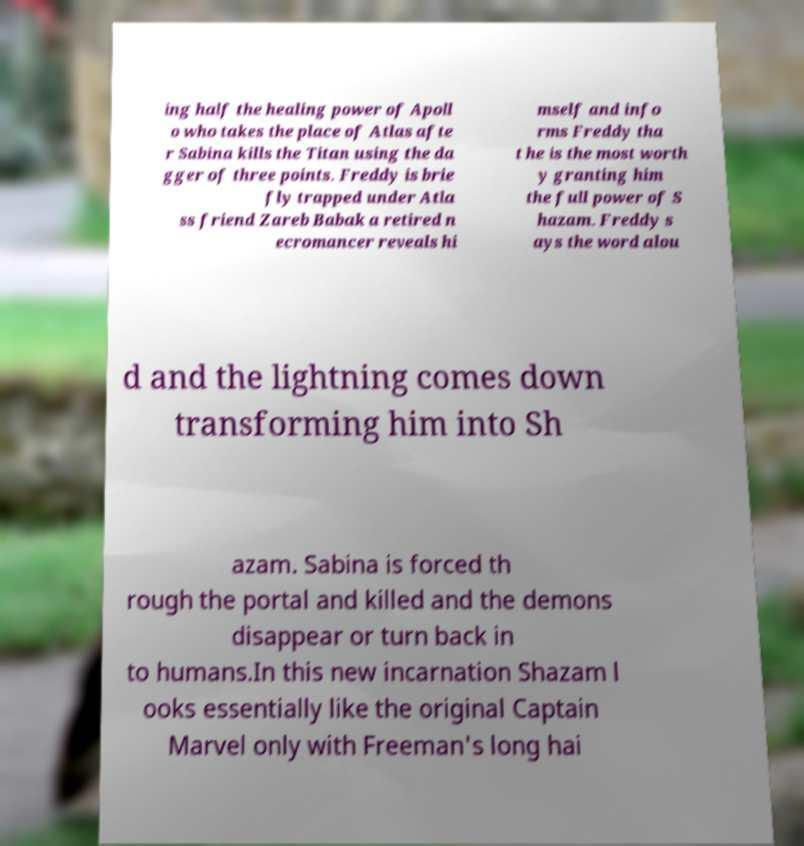Can you accurately transcribe the text from the provided image for me? ing half the healing power of Apoll o who takes the place of Atlas afte r Sabina kills the Titan using the da gger of three points. Freddy is brie fly trapped under Atla ss friend Zareb Babak a retired n ecromancer reveals hi mself and info rms Freddy tha t he is the most worth y granting him the full power of S hazam. Freddy s ays the word alou d and the lightning comes down transforming him into Sh azam. Sabina is forced th rough the portal and killed and the demons disappear or turn back in to humans.In this new incarnation Shazam l ooks essentially like the original Captain Marvel only with Freeman's long hai 